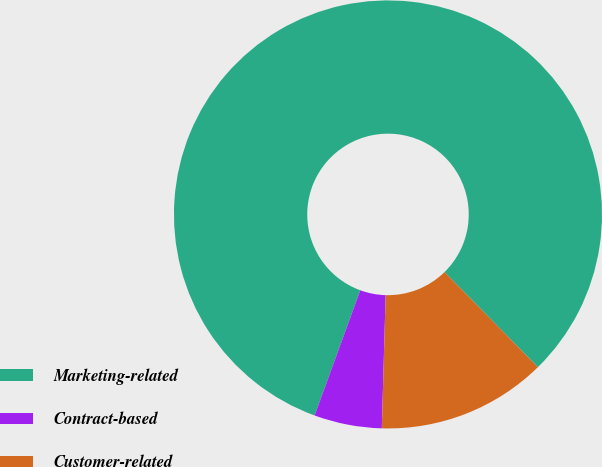Convert chart. <chart><loc_0><loc_0><loc_500><loc_500><pie_chart><fcel>Marketing-related<fcel>Contract-based<fcel>Customer-related<nl><fcel>82.08%<fcel>5.11%<fcel>12.81%<nl></chart> 